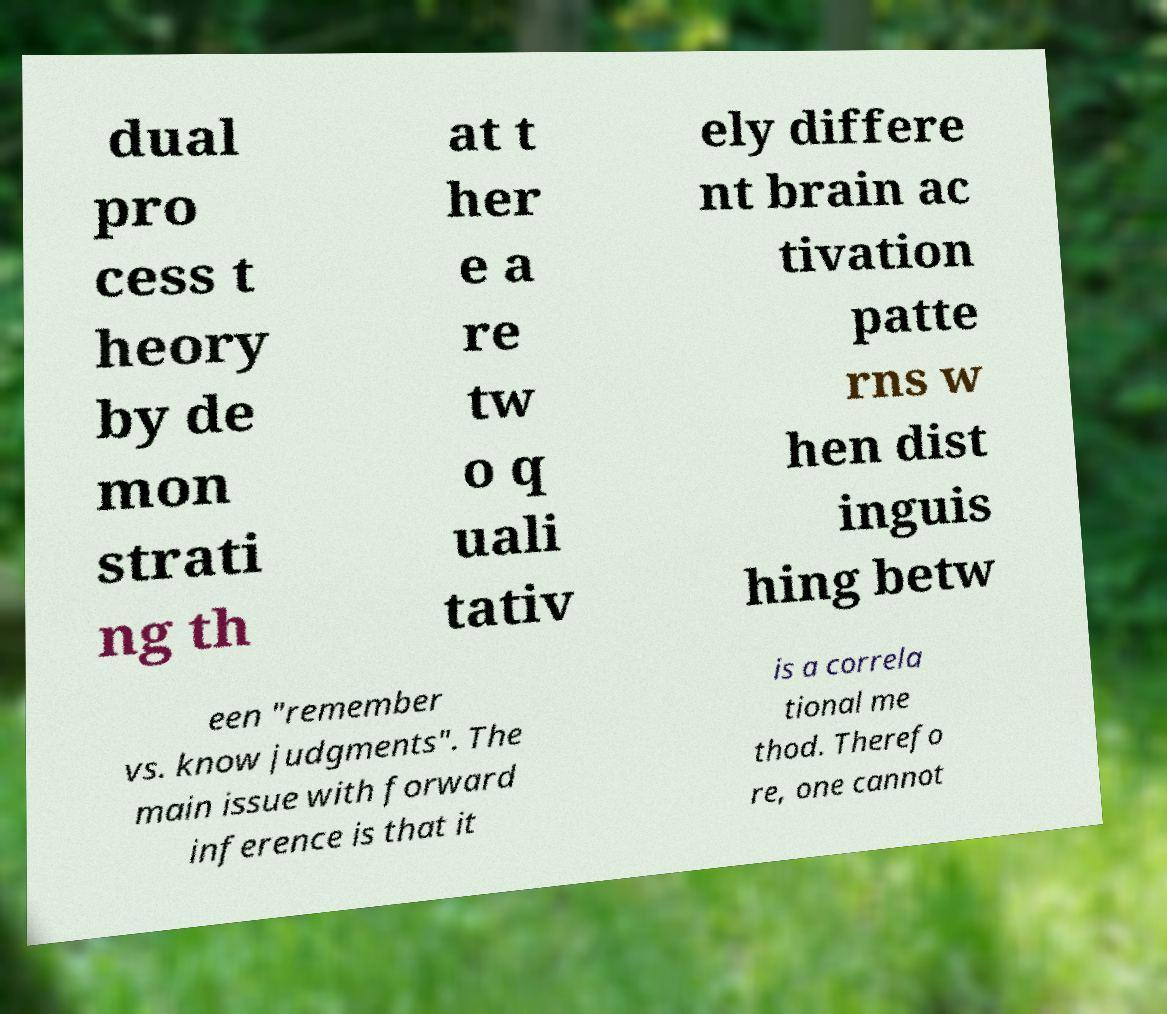Can you read and provide the text displayed in the image?This photo seems to have some interesting text. Can you extract and type it out for me? dual pro cess t heory by de mon strati ng th at t her e a re tw o q uali tativ ely differe nt brain ac tivation patte rns w hen dist inguis hing betw een "remember vs. know judgments". The main issue with forward inference is that it is a correla tional me thod. Therefo re, one cannot 